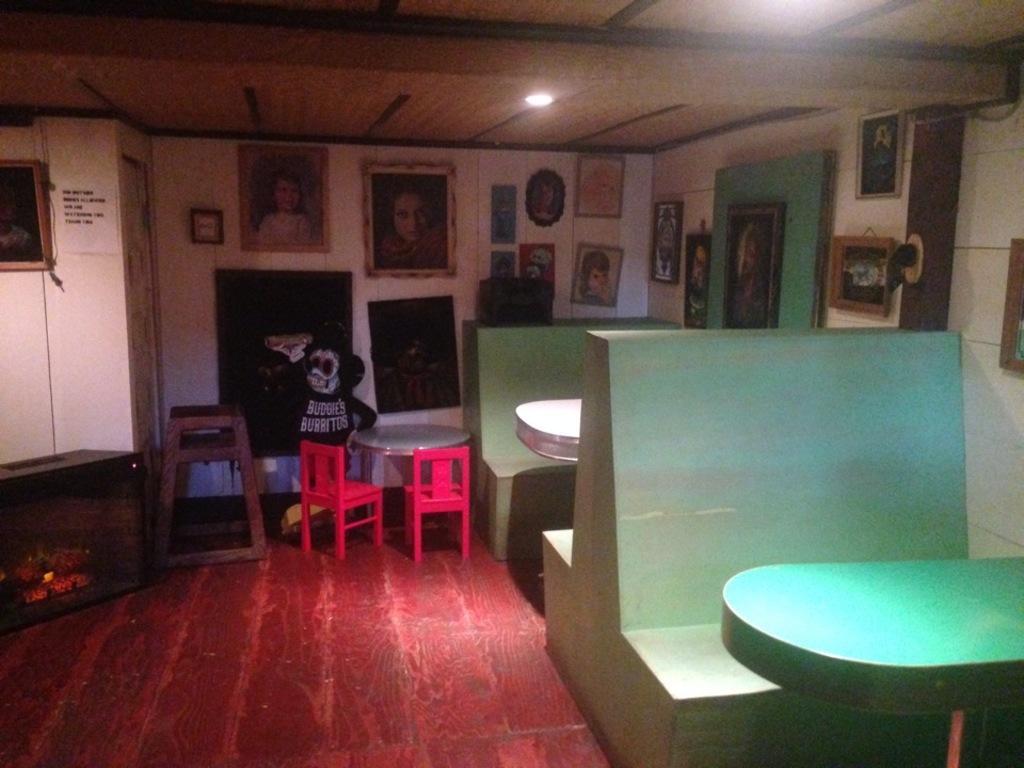Could you give a brief overview of what you see in this image? In this picture we can see few chairs, tables and a light, and also we can see few frames on the walls. 